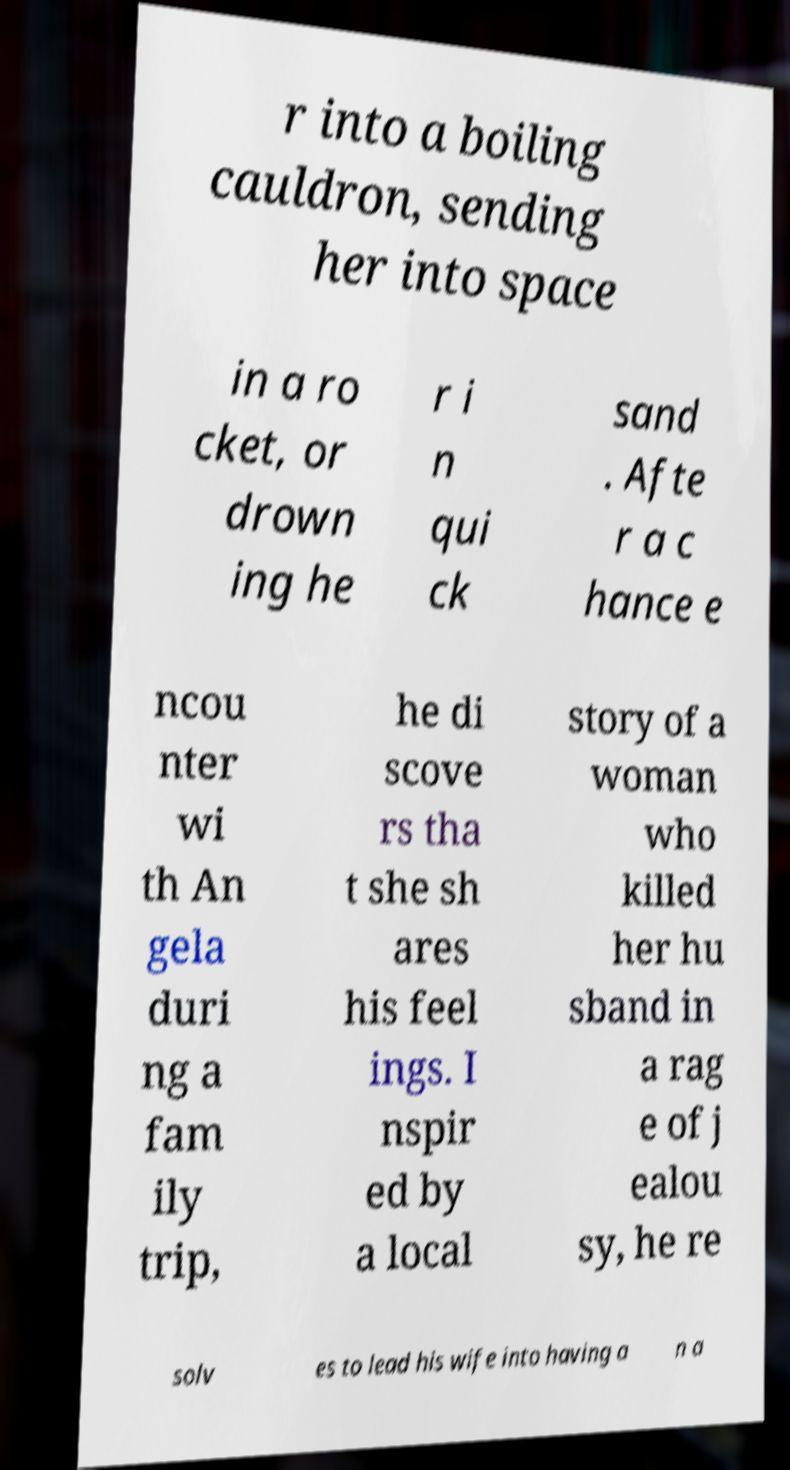Can you accurately transcribe the text from the provided image for me? r into a boiling cauldron, sending her into space in a ro cket, or drown ing he r i n qui ck sand . Afte r a c hance e ncou nter wi th An gela duri ng a fam ily trip, he di scove rs tha t she sh ares his feel ings. I nspir ed by a local story of a woman who killed her hu sband in a rag e of j ealou sy, he re solv es to lead his wife into having a n a 